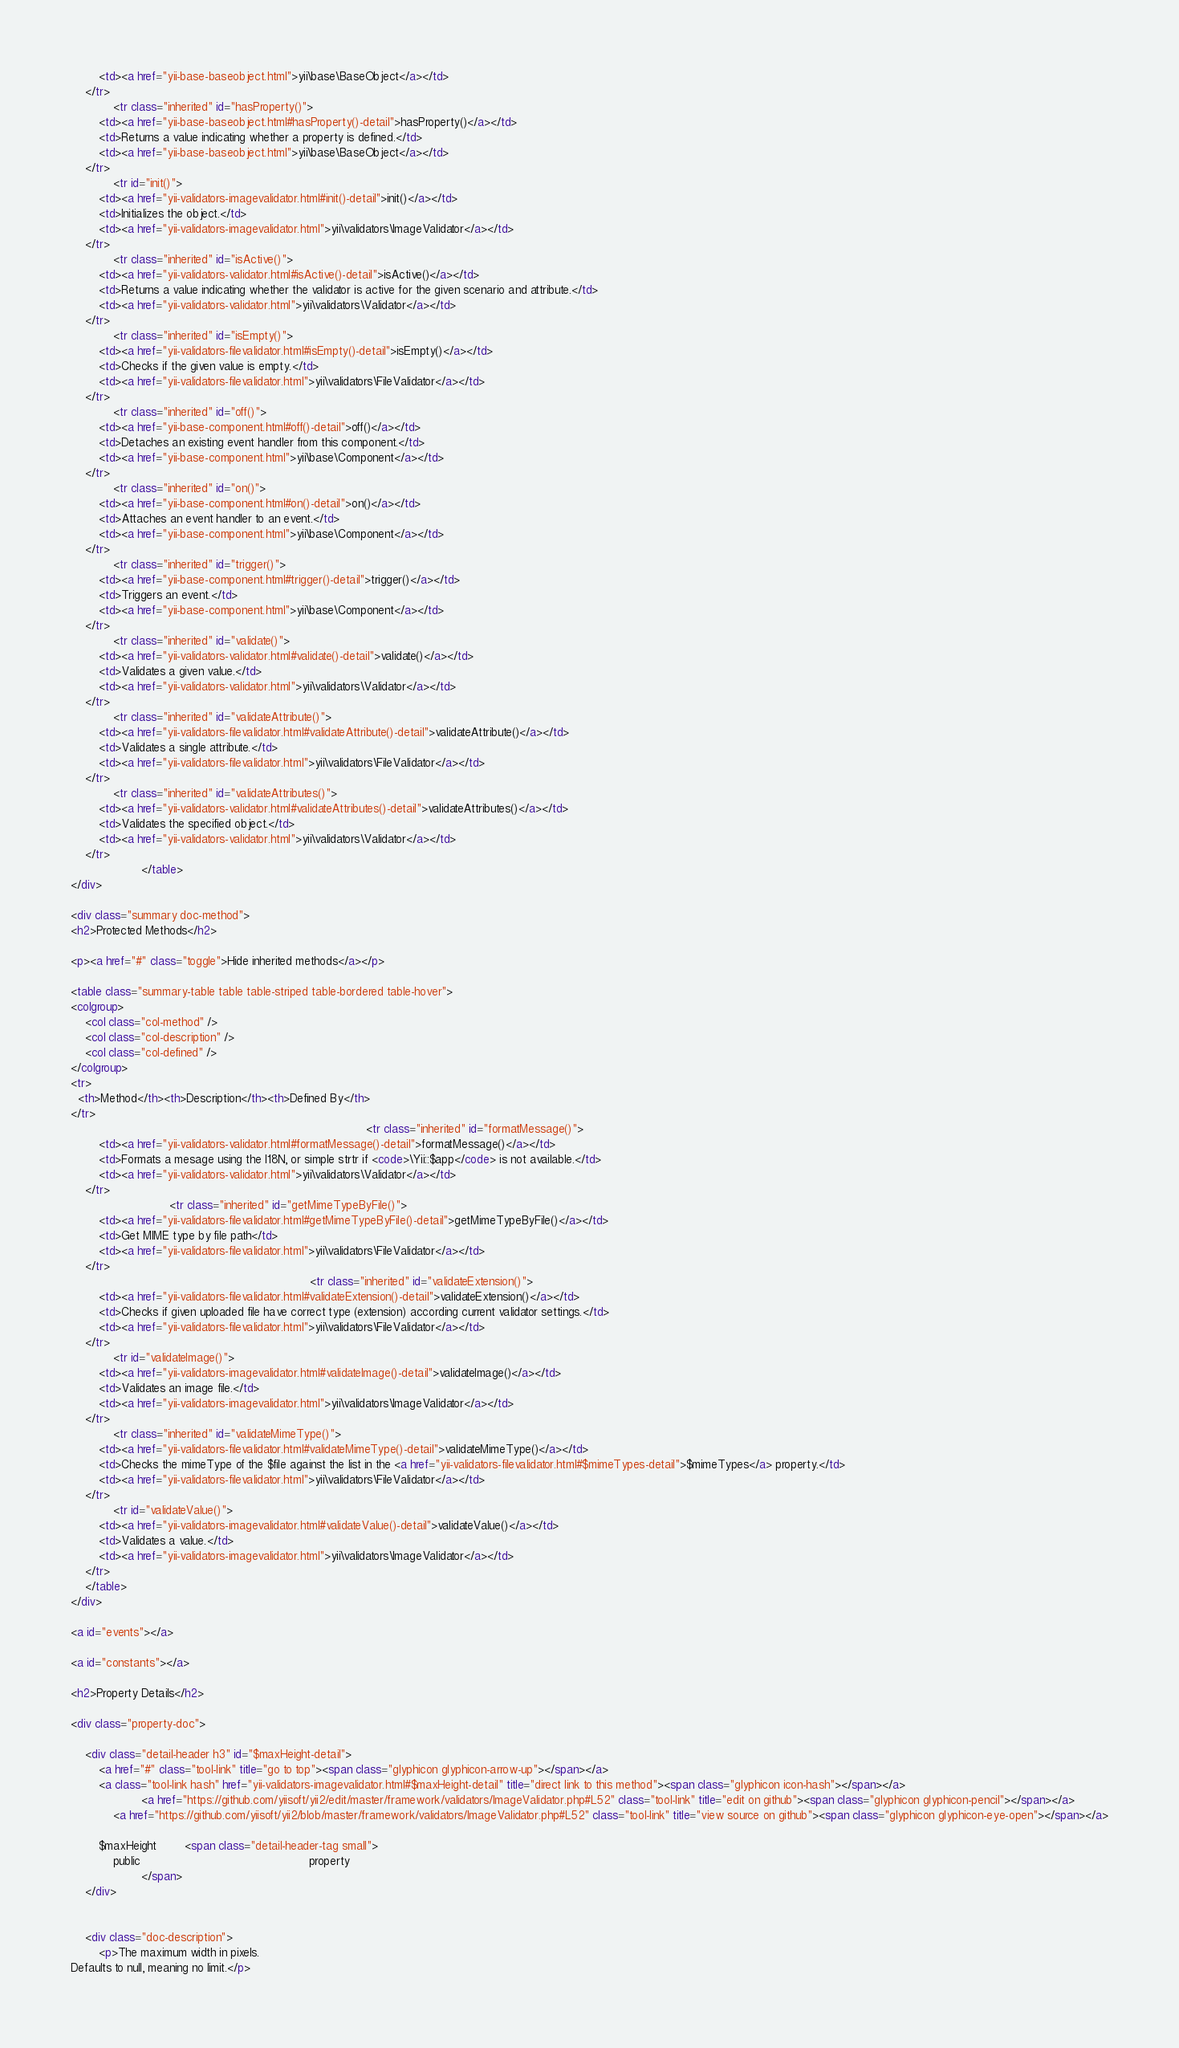Convert code to text. <code><loc_0><loc_0><loc_500><loc_500><_HTML_>        <td><a href="yii-base-baseobject.html">yii\base\BaseObject</a></td>
    </tr>
            <tr class="inherited" id="hasProperty()">
        <td><a href="yii-base-baseobject.html#hasProperty()-detail">hasProperty()</a></td>
        <td>Returns a value indicating whether a property is defined.</td>
        <td><a href="yii-base-baseobject.html">yii\base\BaseObject</a></td>
    </tr>
            <tr id="init()">
        <td><a href="yii-validators-imagevalidator.html#init()-detail">init()</a></td>
        <td>Initializes the object.</td>
        <td><a href="yii-validators-imagevalidator.html">yii\validators\ImageValidator</a></td>
    </tr>
            <tr class="inherited" id="isActive()">
        <td><a href="yii-validators-validator.html#isActive()-detail">isActive()</a></td>
        <td>Returns a value indicating whether the validator is active for the given scenario and attribute.</td>
        <td><a href="yii-validators-validator.html">yii\validators\Validator</a></td>
    </tr>
            <tr class="inherited" id="isEmpty()">
        <td><a href="yii-validators-filevalidator.html#isEmpty()-detail">isEmpty()</a></td>
        <td>Checks if the given value is empty.</td>
        <td><a href="yii-validators-filevalidator.html">yii\validators\FileValidator</a></td>
    </tr>
            <tr class="inherited" id="off()">
        <td><a href="yii-base-component.html#off()-detail">off()</a></td>
        <td>Detaches an existing event handler from this component.</td>
        <td><a href="yii-base-component.html">yii\base\Component</a></td>
    </tr>
            <tr class="inherited" id="on()">
        <td><a href="yii-base-component.html#on()-detail">on()</a></td>
        <td>Attaches an event handler to an event.</td>
        <td><a href="yii-base-component.html">yii\base\Component</a></td>
    </tr>
            <tr class="inherited" id="trigger()">
        <td><a href="yii-base-component.html#trigger()-detail">trigger()</a></td>
        <td>Triggers an event.</td>
        <td><a href="yii-base-component.html">yii\base\Component</a></td>
    </tr>
            <tr class="inherited" id="validate()">
        <td><a href="yii-validators-validator.html#validate()-detail">validate()</a></td>
        <td>Validates a given value.</td>
        <td><a href="yii-validators-validator.html">yii\validators\Validator</a></td>
    </tr>
            <tr class="inherited" id="validateAttribute()">
        <td><a href="yii-validators-filevalidator.html#validateAttribute()-detail">validateAttribute()</a></td>
        <td>Validates a single attribute.</td>
        <td><a href="yii-validators-filevalidator.html">yii\validators\FileValidator</a></td>
    </tr>
            <tr class="inherited" id="validateAttributes()">
        <td><a href="yii-validators-validator.html#validateAttributes()-detail">validateAttributes()</a></td>
        <td>Validates the specified object.</td>
        <td><a href="yii-validators-validator.html">yii\validators\Validator</a></td>
    </tr>
                    </table>
</div>

<div class="summary doc-method">
<h2>Protected Methods</h2>

<p><a href="#" class="toggle">Hide inherited methods</a></p>

<table class="summary-table table table-striped table-bordered table-hover">
<colgroup>
    <col class="col-method" />
    <col class="col-description" />
    <col class="col-defined" />
</colgroup>
<tr>
  <th>Method</th><th>Description</th><th>Defined By</th>
</tr>
                                                                                    <tr class="inherited" id="formatMessage()">
        <td><a href="yii-validators-validator.html#formatMessage()-detail">formatMessage()</a></td>
        <td>Formats a mesage using the I18N, or simple strtr if <code>\Yii::$app</code> is not available.</td>
        <td><a href="yii-validators-validator.html">yii\validators\Validator</a></td>
    </tr>
                            <tr class="inherited" id="getMimeTypeByFile()">
        <td><a href="yii-validators-filevalidator.html#getMimeTypeByFile()-detail">getMimeTypeByFile()</a></td>
        <td>Get MIME type by file path</td>
        <td><a href="yii-validators-filevalidator.html">yii\validators\FileValidator</a></td>
    </tr>
                                                                    <tr class="inherited" id="validateExtension()">
        <td><a href="yii-validators-filevalidator.html#validateExtension()-detail">validateExtension()</a></td>
        <td>Checks if given uploaded file have correct type (extension) according current validator settings.</td>
        <td><a href="yii-validators-filevalidator.html">yii\validators\FileValidator</a></td>
    </tr>
            <tr id="validateImage()">
        <td><a href="yii-validators-imagevalidator.html#validateImage()-detail">validateImage()</a></td>
        <td>Validates an image file.</td>
        <td><a href="yii-validators-imagevalidator.html">yii\validators\ImageValidator</a></td>
    </tr>
            <tr class="inherited" id="validateMimeType()">
        <td><a href="yii-validators-filevalidator.html#validateMimeType()-detail">validateMimeType()</a></td>
        <td>Checks the mimeType of the $file against the list in the <a href="yii-validators-filevalidator.html#$mimeTypes-detail">$mimeTypes</a> property.</td>
        <td><a href="yii-validators-filevalidator.html">yii\validators\FileValidator</a></td>
    </tr>
            <tr id="validateValue()">
        <td><a href="yii-validators-imagevalidator.html#validateValue()-detail">validateValue()</a></td>
        <td>Validates a value.</td>
        <td><a href="yii-validators-imagevalidator.html">yii\validators\ImageValidator</a></td>
    </tr>
    </table>
</div>

<a id="events"></a>

<a id="constants"></a>

<h2>Property Details</h2>

<div class="property-doc">

    <div class="detail-header h3" id="$maxHeight-detail">
        <a href="#" class="tool-link" title="go to top"><span class="glyphicon glyphicon-arrow-up"></span></a>
        <a class="tool-link hash" href="yii-validators-imagevalidator.html#$maxHeight-detail" title="direct link to this method"><span class="glyphicon icon-hash"></span></a>
                    <a href="https://github.com/yiisoft/yii2/edit/master/framework/validators/ImageValidator.php#L52" class="tool-link" title="edit on github"><span class="glyphicon glyphicon-pencil"></span></a>
            <a href="https://github.com/yiisoft/yii2/blob/master/framework/validators/ImageValidator.php#L52" class="tool-link" title="view source on github"><span class="glyphicon glyphicon-eye-open"></span></a>
        
        $maxHeight        <span class="detail-header-tag small">
            public                                                property
                    </span>
    </div>

    
    <div class="doc-description">
        <p>The maximum width in pixels.
Defaults to null, meaning no limit.</p>
</code> 